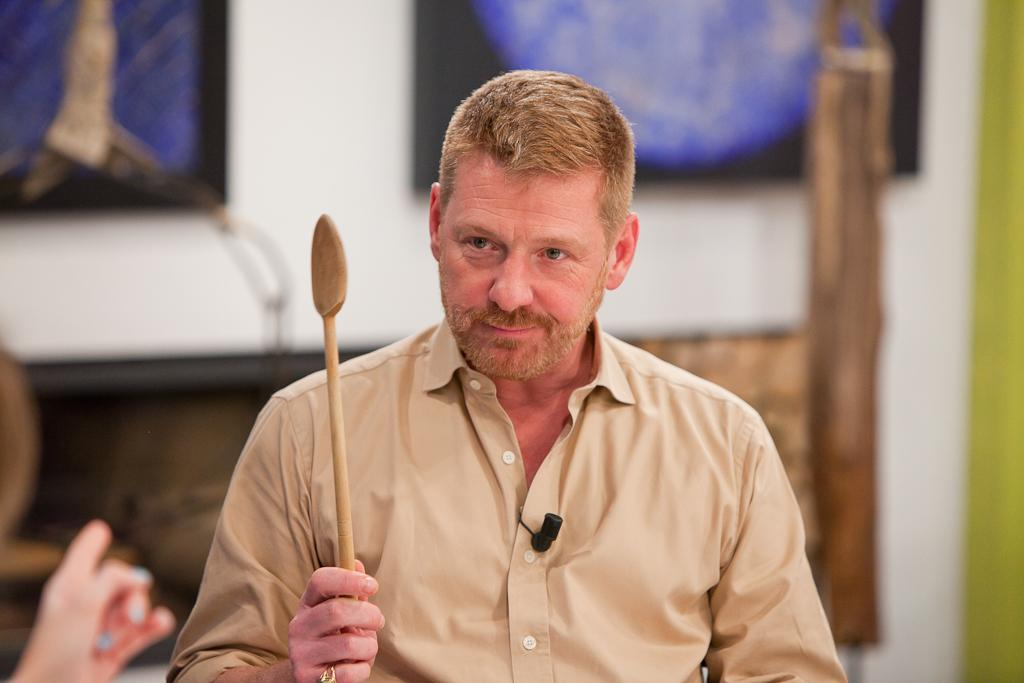What can be seen in the background of the image? There is a wall in the background of the image. What is on the wall? There are frames on the wall. Who is in the image? There is a man in the image. What is the man wearing? The man is wearing a shirt. What is the man holding in his hand? The man is holding a wooden spoon in his hand. How much sugar is in the man's stomach in the image? There is no information about the man's stomach or sugar content in the image, so it cannot be determined. 